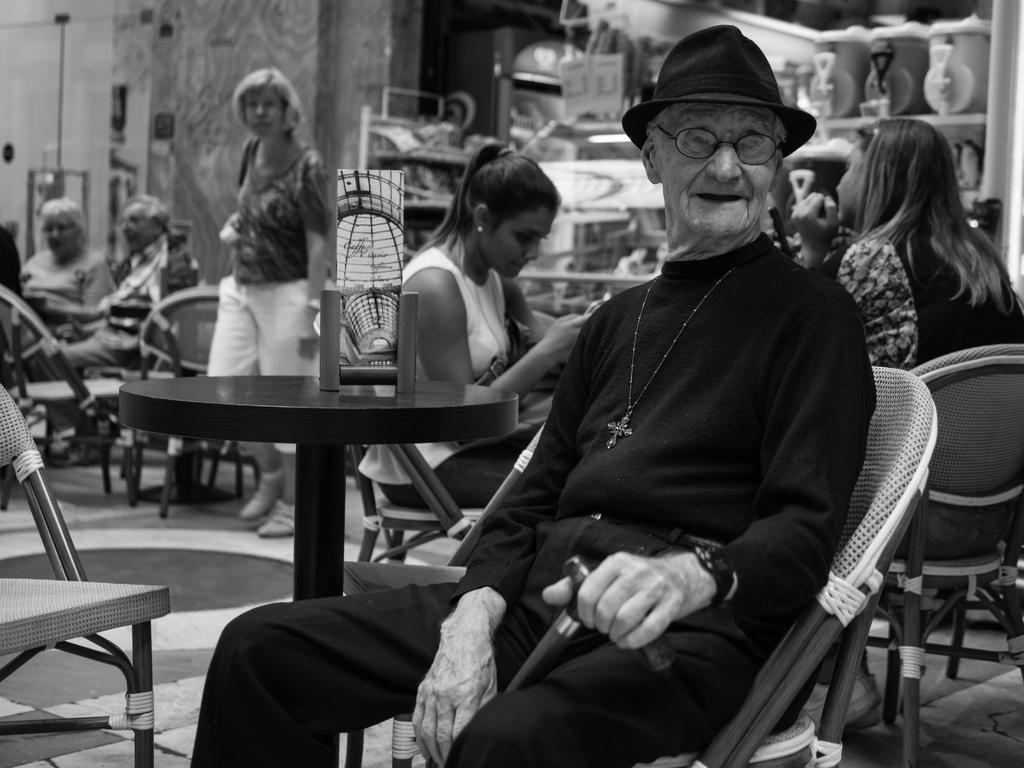Who is present in the image? There is a man in the image. What is the man doing in the image? The man is sitting on a chair. Are there any other people in the image? Yes, there are other people sitting on chairs in the image. What is the man wearing on his head? The man is wearing a black cap. What is the color scheme of the image? The image is in black and white color. What type of fruit is the man holding in the image? There is no fruit present in the image; the man is sitting on a chair and wearing a black cap. Can you tell me the name of the porter who is serving the man in the image? There is no porter or serving activity depicted in the image. 